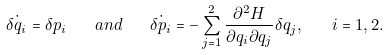Convert formula to latex. <formula><loc_0><loc_0><loc_500><loc_500>\dot { \delta q _ { i } } = \delta p _ { i } \quad a n d \quad \dot { \delta p _ { i } } = - \sum _ { j = 1 } ^ { 2 } \frac { \partial ^ { 2 } H } { \partial q _ { i } \partial q _ { j } } \delta q _ { j } , \quad i = 1 , 2 .</formula> 